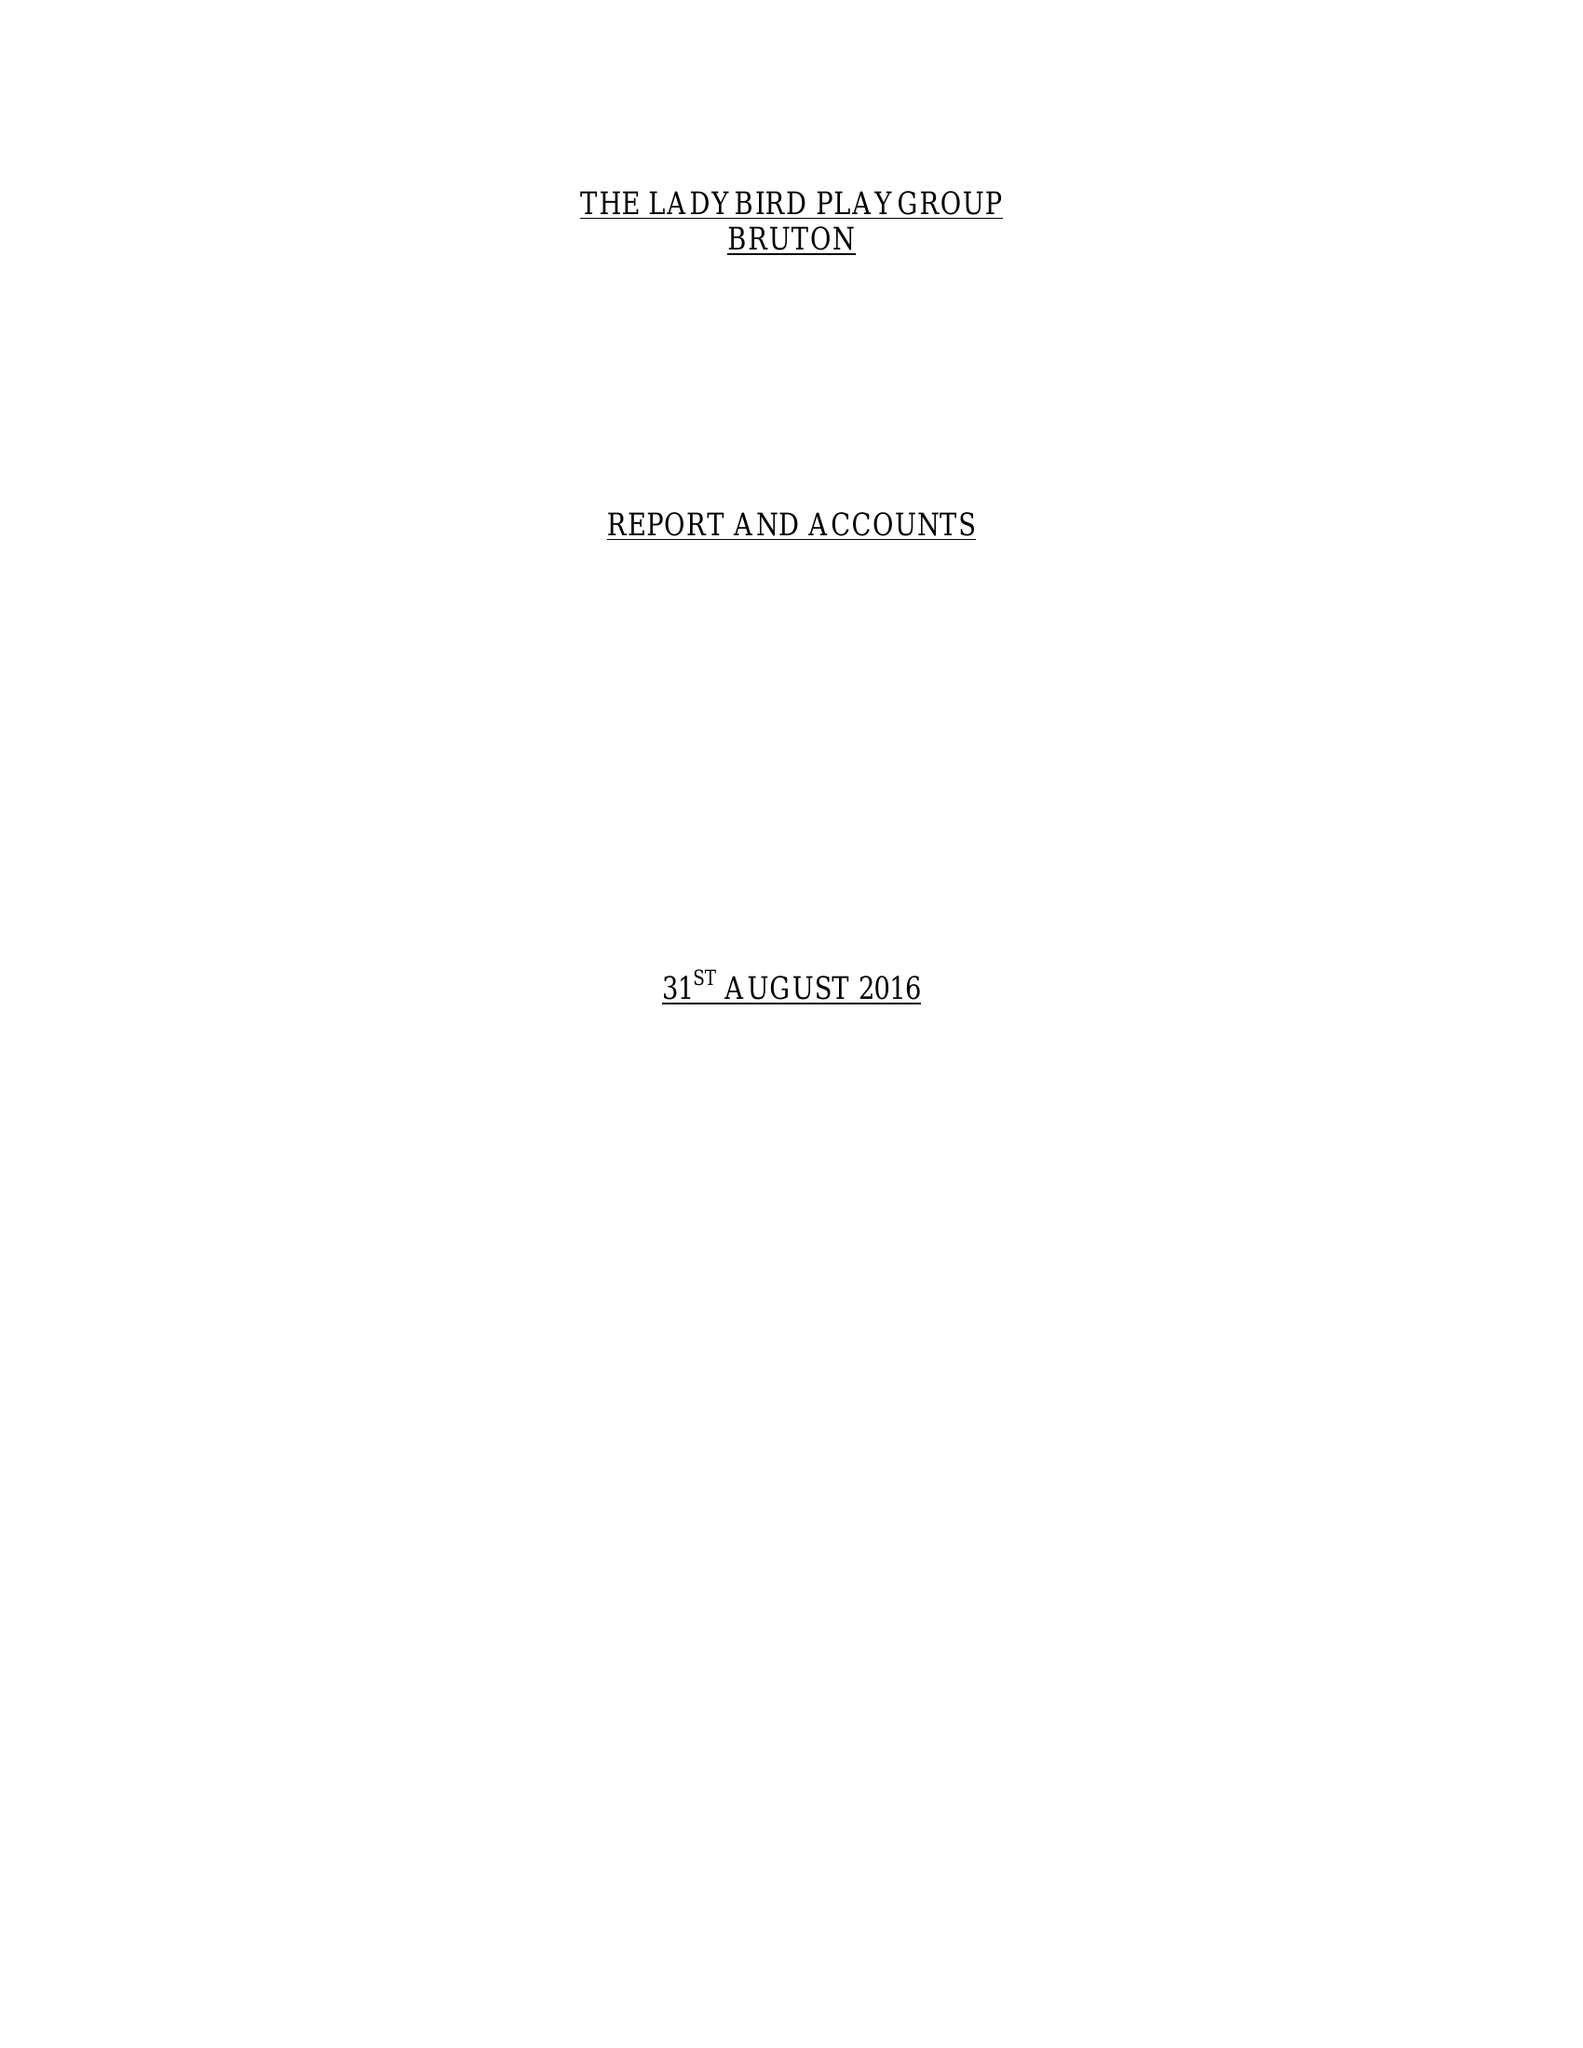What is the value for the spending_annually_in_british_pounds?
Answer the question using a single word or phrase. 67955.00 